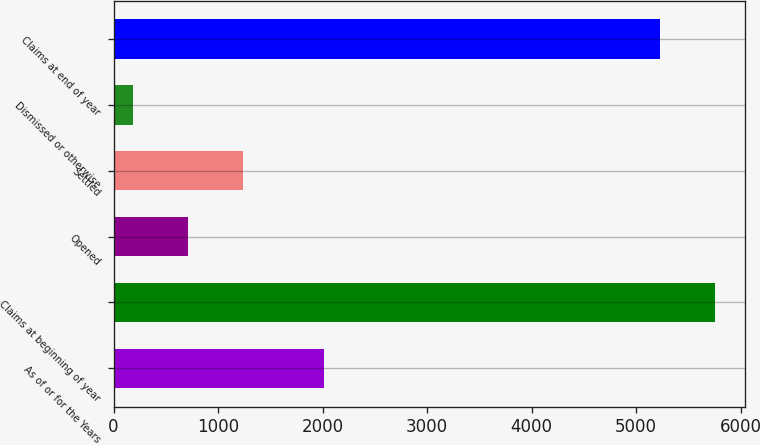<chart> <loc_0><loc_0><loc_500><loc_500><bar_chart><fcel>As of or for the Years<fcel>Claims at beginning of year<fcel>Opened<fcel>Settled<fcel>Dismissed or otherwise<fcel>Claims at end of year<nl><fcel>2012<fcel>5755.8<fcel>710.8<fcel>1236.6<fcel>185<fcel>5230<nl></chart> 